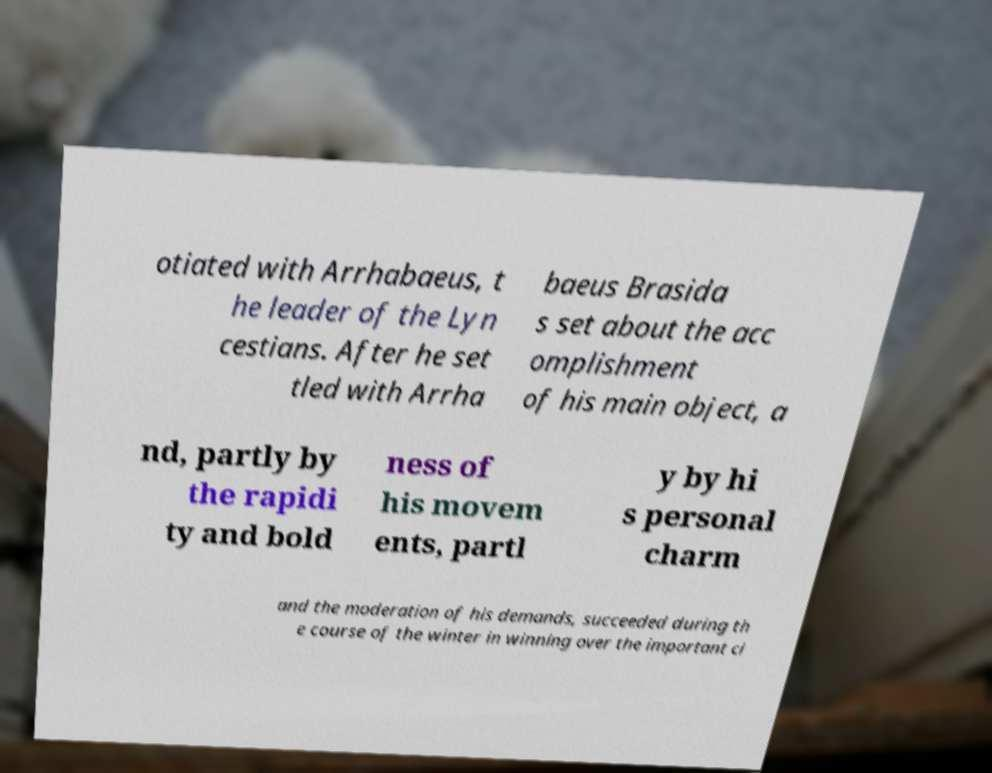Please identify and transcribe the text found in this image. otiated with Arrhabaeus, t he leader of the Lyn cestians. After he set tled with Arrha baeus Brasida s set about the acc omplishment of his main object, a nd, partly by the rapidi ty and bold ness of his movem ents, partl y by hi s personal charm and the moderation of his demands, succeeded during th e course of the winter in winning over the important ci 